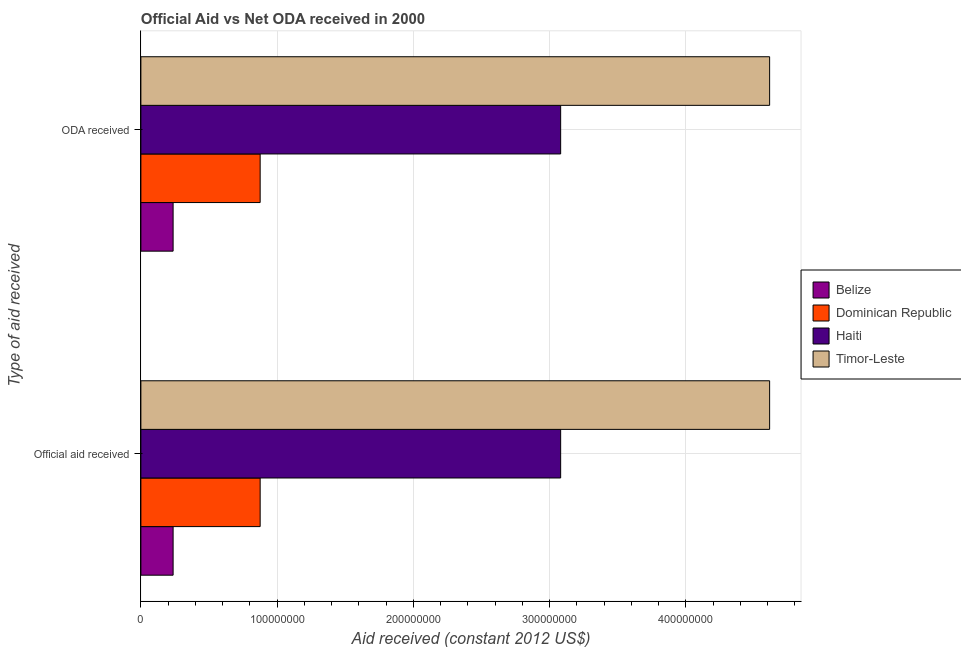How many groups of bars are there?
Your response must be concise. 2. Are the number of bars per tick equal to the number of legend labels?
Your answer should be compact. Yes. Are the number of bars on each tick of the Y-axis equal?
Provide a short and direct response. Yes. How many bars are there on the 1st tick from the bottom?
Provide a short and direct response. 4. What is the label of the 2nd group of bars from the top?
Give a very brief answer. Official aid received. What is the official aid received in Haiti?
Your answer should be very brief. 3.08e+08. Across all countries, what is the maximum oda received?
Provide a succinct answer. 4.61e+08. Across all countries, what is the minimum oda received?
Your answer should be compact. 2.36e+07. In which country was the official aid received maximum?
Your response must be concise. Timor-Leste. In which country was the oda received minimum?
Offer a terse response. Belize. What is the total official aid received in the graph?
Your answer should be compact. 8.81e+08. What is the difference between the oda received in Dominican Republic and that in Haiti?
Give a very brief answer. -2.21e+08. What is the difference between the official aid received in Belize and the oda received in Dominican Republic?
Offer a very short reply. -6.39e+07. What is the average oda received per country?
Provide a short and direct response. 2.20e+08. In how many countries, is the official aid received greater than 320000000 US$?
Ensure brevity in your answer.  1. What is the ratio of the oda received in Dominican Republic to that in Timor-Leste?
Keep it short and to the point. 0.19. Is the official aid received in Haiti less than that in Timor-Leste?
Keep it short and to the point. Yes. What does the 1st bar from the top in Official aid received represents?
Your answer should be compact. Timor-Leste. What does the 2nd bar from the bottom in ODA received represents?
Ensure brevity in your answer.  Dominican Republic. How many bars are there?
Offer a very short reply. 8. How many countries are there in the graph?
Keep it short and to the point. 4. What is the difference between two consecutive major ticks on the X-axis?
Your answer should be compact. 1.00e+08. Does the graph contain any zero values?
Offer a very short reply. No. What is the title of the graph?
Offer a very short reply. Official Aid vs Net ODA received in 2000 . Does "Zimbabwe" appear as one of the legend labels in the graph?
Give a very brief answer. No. What is the label or title of the X-axis?
Provide a succinct answer. Aid received (constant 2012 US$). What is the label or title of the Y-axis?
Offer a very short reply. Type of aid received. What is the Aid received (constant 2012 US$) of Belize in Official aid received?
Provide a succinct answer. 2.36e+07. What is the Aid received (constant 2012 US$) in Dominican Republic in Official aid received?
Your answer should be compact. 8.75e+07. What is the Aid received (constant 2012 US$) in Haiti in Official aid received?
Your answer should be compact. 3.08e+08. What is the Aid received (constant 2012 US$) in Timor-Leste in Official aid received?
Offer a very short reply. 4.61e+08. What is the Aid received (constant 2012 US$) of Belize in ODA received?
Provide a succinct answer. 2.36e+07. What is the Aid received (constant 2012 US$) in Dominican Republic in ODA received?
Provide a short and direct response. 8.75e+07. What is the Aid received (constant 2012 US$) of Haiti in ODA received?
Give a very brief answer. 3.08e+08. What is the Aid received (constant 2012 US$) of Timor-Leste in ODA received?
Offer a terse response. 4.61e+08. Across all Type of aid received, what is the maximum Aid received (constant 2012 US$) in Belize?
Offer a very short reply. 2.36e+07. Across all Type of aid received, what is the maximum Aid received (constant 2012 US$) of Dominican Republic?
Your answer should be compact. 8.75e+07. Across all Type of aid received, what is the maximum Aid received (constant 2012 US$) in Haiti?
Ensure brevity in your answer.  3.08e+08. Across all Type of aid received, what is the maximum Aid received (constant 2012 US$) of Timor-Leste?
Your response must be concise. 4.61e+08. Across all Type of aid received, what is the minimum Aid received (constant 2012 US$) in Belize?
Keep it short and to the point. 2.36e+07. Across all Type of aid received, what is the minimum Aid received (constant 2012 US$) in Dominican Republic?
Give a very brief answer. 8.75e+07. Across all Type of aid received, what is the minimum Aid received (constant 2012 US$) of Haiti?
Your answer should be very brief. 3.08e+08. Across all Type of aid received, what is the minimum Aid received (constant 2012 US$) of Timor-Leste?
Provide a succinct answer. 4.61e+08. What is the total Aid received (constant 2012 US$) of Belize in the graph?
Your answer should be compact. 4.73e+07. What is the total Aid received (constant 2012 US$) of Dominican Republic in the graph?
Provide a succinct answer. 1.75e+08. What is the total Aid received (constant 2012 US$) of Haiti in the graph?
Give a very brief answer. 6.16e+08. What is the total Aid received (constant 2012 US$) in Timor-Leste in the graph?
Provide a succinct answer. 9.23e+08. What is the difference between the Aid received (constant 2012 US$) in Dominican Republic in Official aid received and that in ODA received?
Ensure brevity in your answer.  0. What is the difference between the Aid received (constant 2012 US$) of Haiti in Official aid received and that in ODA received?
Provide a short and direct response. 0. What is the difference between the Aid received (constant 2012 US$) in Timor-Leste in Official aid received and that in ODA received?
Your answer should be very brief. 0. What is the difference between the Aid received (constant 2012 US$) of Belize in Official aid received and the Aid received (constant 2012 US$) of Dominican Republic in ODA received?
Offer a very short reply. -6.39e+07. What is the difference between the Aid received (constant 2012 US$) of Belize in Official aid received and the Aid received (constant 2012 US$) of Haiti in ODA received?
Keep it short and to the point. -2.84e+08. What is the difference between the Aid received (constant 2012 US$) of Belize in Official aid received and the Aid received (constant 2012 US$) of Timor-Leste in ODA received?
Your answer should be compact. -4.38e+08. What is the difference between the Aid received (constant 2012 US$) in Dominican Republic in Official aid received and the Aid received (constant 2012 US$) in Haiti in ODA received?
Keep it short and to the point. -2.21e+08. What is the difference between the Aid received (constant 2012 US$) of Dominican Republic in Official aid received and the Aid received (constant 2012 US$) of Timor-Leste in ODA received?
Your answer should be very brief. -3.74e+08. What is the difference between the Aid received (constant 2012 US$) of Haiti in Official aid received and the Aid received (constant 2012 US$) of Timor-Leste in ODA received?
Provide a succinct answer. -1.53e+08. What is the average Aid received (constant 2012 US$) in Belize per Type of aid received?
Provide a short and direct response. 2.36e+07. What is the average Aid received (constant 2012 US$) in Dominican Republic per Type of aid received?
Offer a terse response. 8.75e+07. What is the average Aid received (constant 2012 US$) in Haiti per Type of aid received?
Offer a terse response. 3.08e+08. What is the average Aid received (constant 2012 US$) in Timor-Leste per Type of aid received?
Your response must be concise. 4.61e+08. What is the difference between the Aid received (constant 2012 US$) in Belize and Aid received (constant 2012 US$) in Dominican Republic in Official aid received?
Your response must be concise. -6.39e+07. What is the difference between the Aid received (constant 2012 US$) of Belize and Aid received (constant 2012 US$) of Haiti in Official aid received?
Your answer should be very brief. -2.84e+08. What is the difference between the Aid received (constant 2012 US$) in Belize and Aid received (constant 2012 US$) in Timor-Leste in Official aid received?
Your answer should be compact. -4.38e+08. What is the difference between the Aid received (constant 2012 US$) of Dominican Republic and Aid received (constant 2012 US$) of Haiti in Official aid received?
Provide a short and direct response. -2.21e+08. What is the difference between the Aid received (constant 2012 US$) in Dominican Republic and Aid received (constant 2012 US$) in Timor-Leste in Official aid received?
Your answer should be very brief. -3.74e+08. What is the difference between the Aid received (constant 2012 US$) of Haiti and Aid received (constant 2012 US$) of Timor-Leste in Official aid received?
Give a very brief answer. -1.53e+08. What is the difference between the Aid received (constant 2012 US$) in Belize and Aid received (constant 2012 US$) in Dominican Republic in ODA received?
Provide a succinct answer. -6.39e+07. What is the difference between the Aid received (constant 2012 US$) of Belize and Aid received (constant 2012 US$) of Haiti in ODA received?
Provide a succinct answer. -2.84e+08. What is the difference between the Aid received (constant 2012 US$) in Belize and Aid received (constant 2012 US$) in Timor-Leste in ODA received?
Provide a short and direct response. -4.38e+08. What is the difference between the Aid received (constant 2012 US$) of Dominican Republic and Aid received (constant 2012 US$) of Haiti in ODA received?
Provide a short and direct response. -2.21e+08. What is the difference between the Aid received (constant 2012 US$) of Dominican Republic and Aid received (constant 2012 US$) of Timor-Leste in ODA received?
Offer a very short reply. -3.74e+08. What is the difference between the Aid received (constant 2012 US$) in Haiti and Aid received (constant 2012 US$) in Timor-Leste in ODA received?
Your answer should be compact. -1.53e+08. What is the ratio of the Aid received (constant 2012 US$) of Dominican Republic in Official aid received to that in ODA received?
Offer a very short reply. 1. What is the ratio of the Aid received (constant 2012 US$) of Haiti in Official aid received to that in ODA received?
Offer a very short reply. 1. What is the ratio of the Aid received (constant 2012 US$) of Timor-Leste in Official aid received to that in ODA received?
Provide a succinct answer. 1. What is the difference between the highest and the second highest Aid received (constant 2012 US$) in Dominican Republic?
Offer a terse response. 0. What is the difference between the highest and the lowest Aid received (constant 2012 US$) in Belize?
Keep it short and to the point. 0. What is the difference between the highest and the lowest Aid received (constant 2012 US$) in Dominican Republic?
Make the answer very short. 0. 